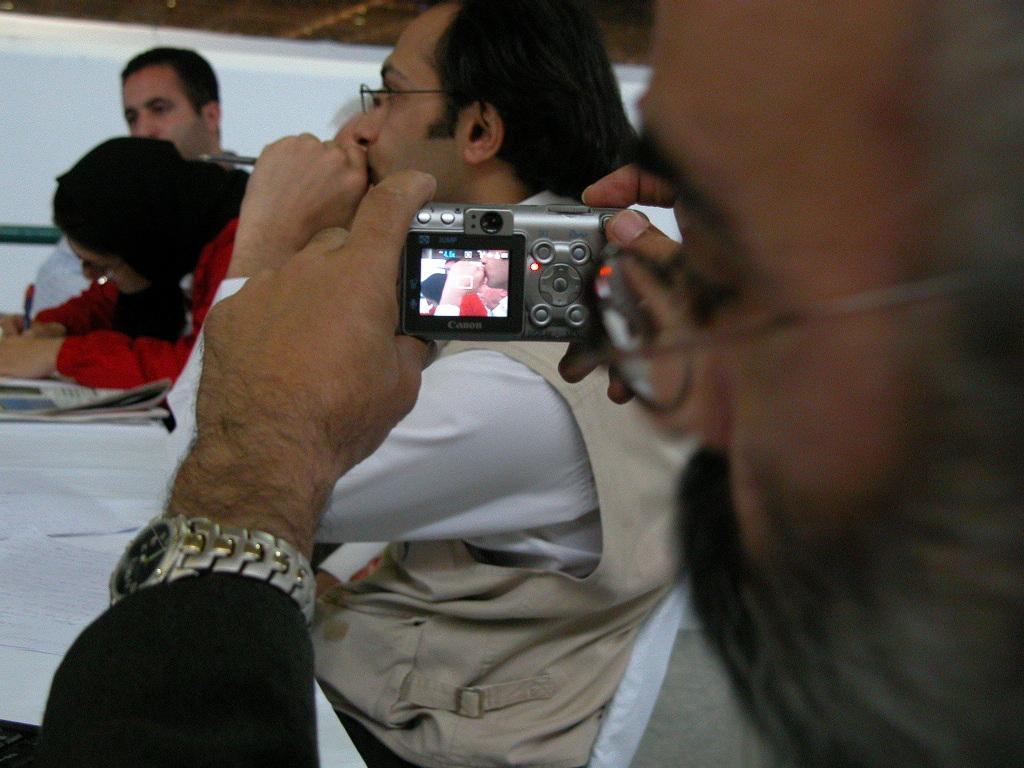What are the people in the image doing? The people in the image are sitting. What object is the man holding in his hand? The man is holding a camera in his hand. What other object is the man holding in his hand? The man is also holding a watch in his hand. What type of nail is the man using to stretch the camera in the image? There is no nail present in the image, and the camera is not being stretched. 